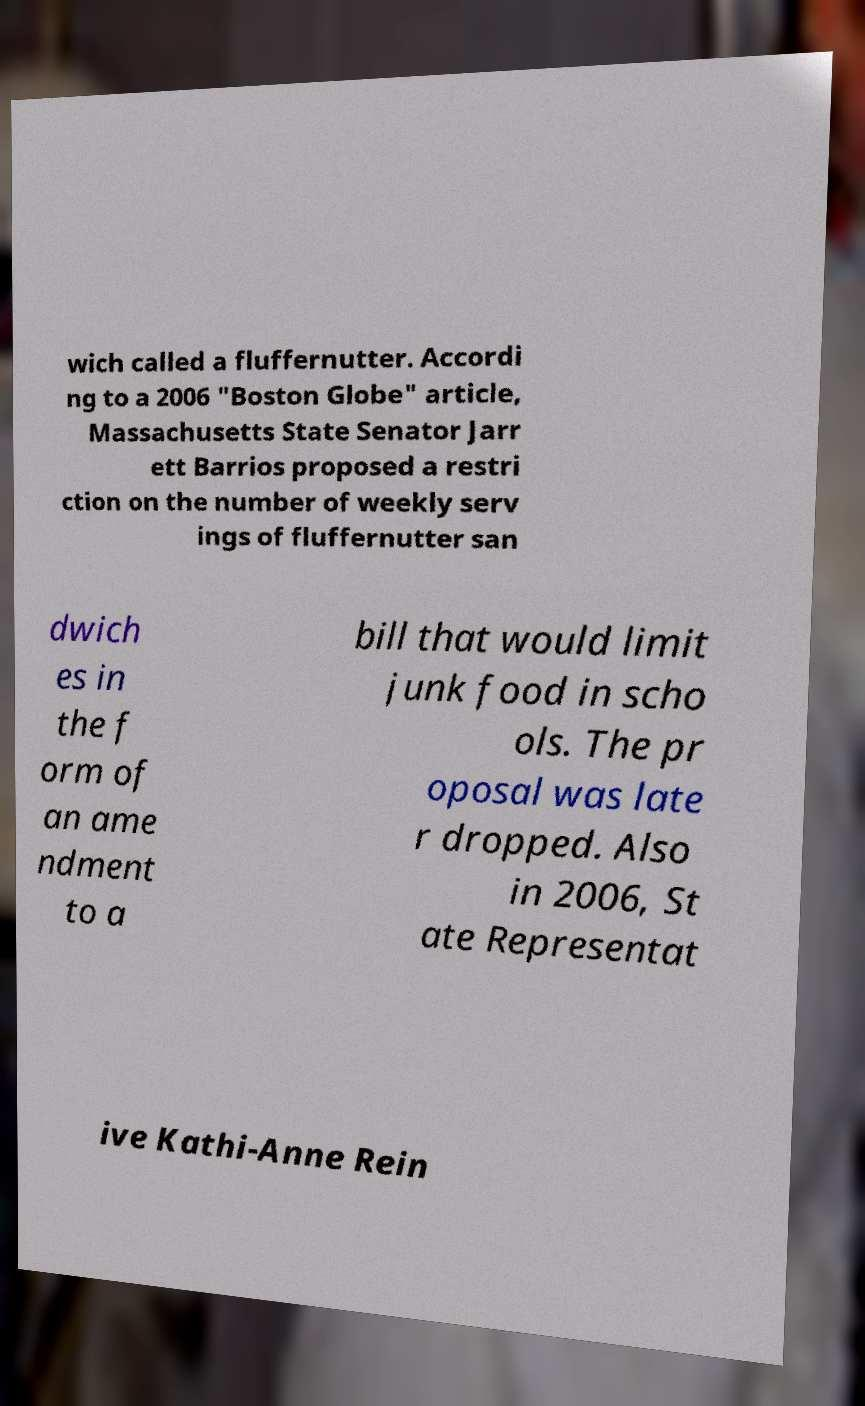Could you extract and type out the text from this image? wich called a fluffernutter. Accordi ng to a 2006 "Boston Globe" article, Massachusetts State Senator Jarr ett Barrios proposed a restri ction on the number of weekly serv ings of fluffernutter san dwich es in the f orm of an ame ndment to a bill that would limit junk food in scho ols. The pr oposal was late r dropped. Also in 2006, St ate Representat ive Kathi-Anne Rein 